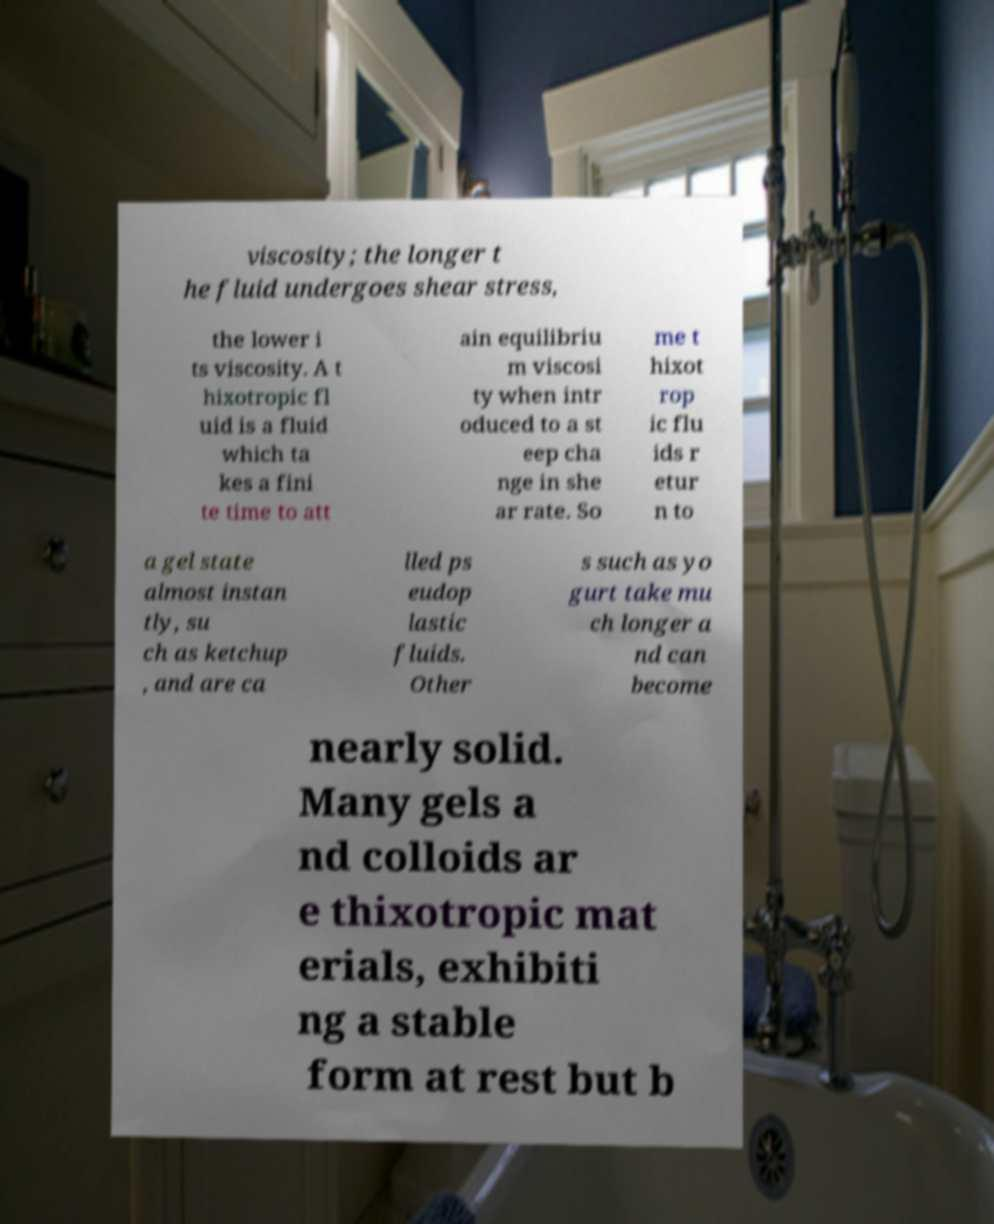Please read and relay the text visible in this image. What does it say? viscosity; the longer t he fluid undergoes shear stress, the lower i ts viscosity. A t hixotropic fl uid is a fluid which ta kes a fini te time to att ain equilibriu m viscosi ty when intr oduced to a st eep cha nge in she ar rate. So me t hixot rop ic flu ids r etur n to a gel state almost instan tly, su ch as ketchup , and are ca lled ps eudop lastic fluids. Other s such as yo gurt take mu ch longer a nd can become nearly solid. Many gels a nd colloids ar e thixotropic mat erials, exhibiti ng a stable form at rest but b 